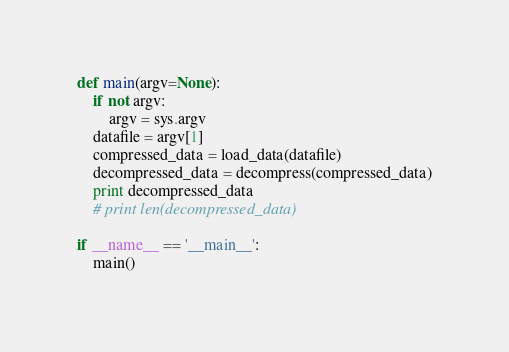<code> <loc_0><loc_0><loc_500><loc_500><_Python_>def main(argv=None):
    if not argv:
        argv = sys.argv
    datafile = argv[1]
    compressed_data = load_data(datafile)
    decompressed_data = decompress(compressed_data)
    print decompressed_data
    # print len(decompressed_data)

if __name__ == '__main__':
    main()
</code> 